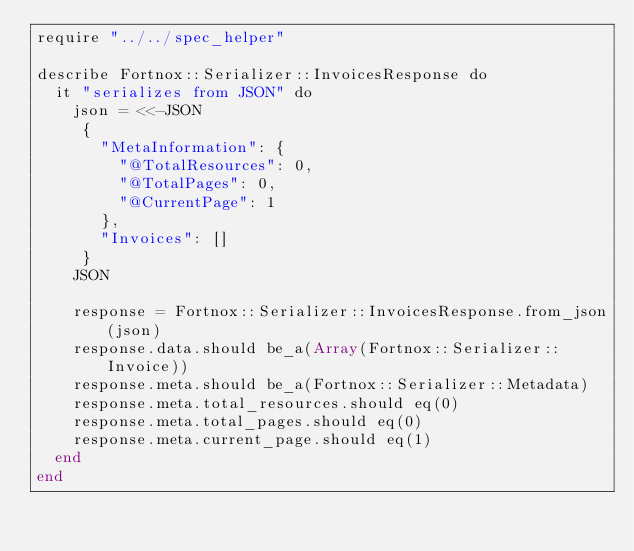Convert code to text. <code><loc_0><loc_0><loc_500><loc_500><_Crystal_>require "../../spec_helper"

describe Fortnox::Serializer::InvoicesResponse do
  it "serializes from JSON" do
    json = <<-JSON
     {
       "MetaInformation": {
         "@TotalResources": 0,
         "@TotalPages": 0,
         "@CurrentPage": 1
       },
       "Invoices": []
     }
    JSON

    response = Fortnox::Serializer::InvoicesResponse.from_json(json)
    response.data.should be_a(Array(Fortnox::Serializer::Invoice))
    response.meta.should be_a(Fortnox::Serializer::Metadata)
    response.meta.total_resources.should eq(0)
    response.meta.total_pages.should eq(0)
    response.meta.current_page.should eq(1)
  end
end
</code> 